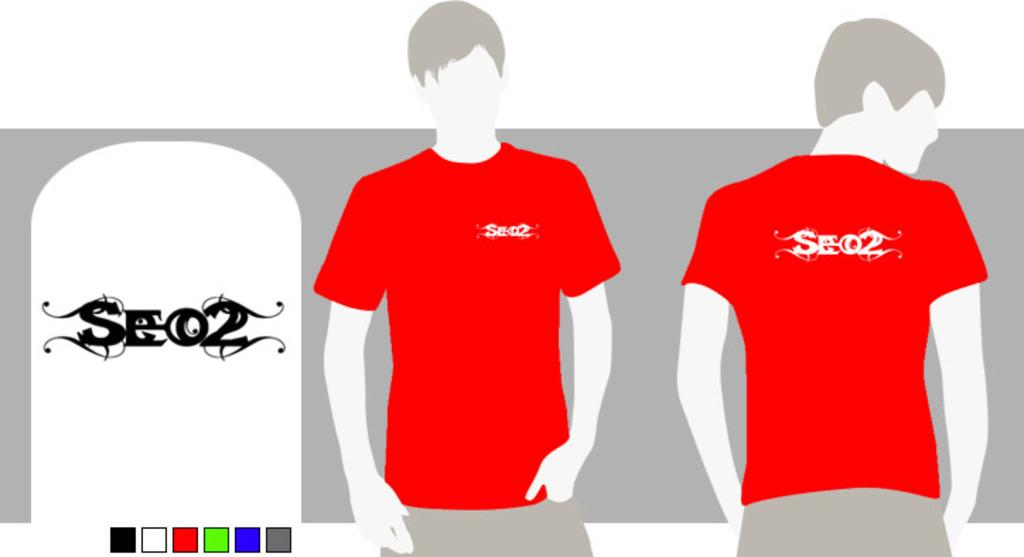Provide a one-sentence caption for the provided image. A graphic for a shirt taht reads SE 02. 